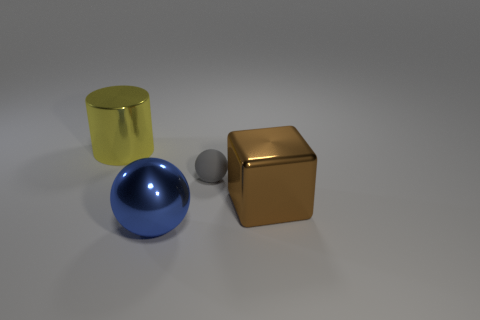Add 4 large yellow metallic objects. How many objects exist? 8 Subtract all cylinders. How many objects are left? 3 Add 2 brown blocks. How many brown blocks exist? 3 Subtract 0 purple blocks. How many objects are left? 4 Subtract all big metallic cylinders. Subtract all matte balls. How many objects are left? 2 Add 1 large metallic objects. How many large metallic objects are left? 4 